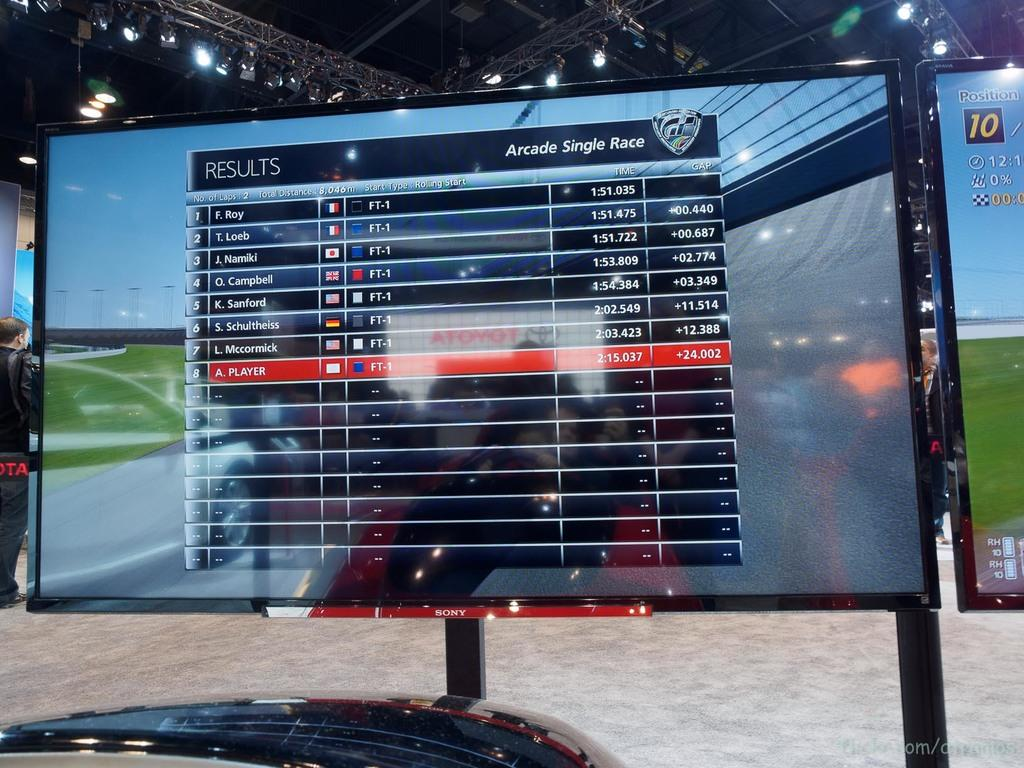<image>
Share a concise interpretation of the image provided. A large television shows the results of the arcade single race. 